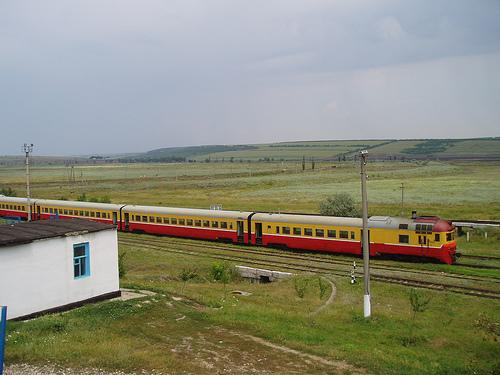What type of building is situated near the train? A small white building with a black roof and blue window frame. Are there any objects situated around the train that are related to transportation infrastructure? Yes, there are railroad tracks, a concrete entrance that goes under the tracks, and a tall wooden pole with a white base. Count the number of cars visible in the train. Four cars. What does the sky look like in the image? The sky is gray and hazy, with clouds indicating a possible overcast day. Identify any unique features on the small building near the train. The small building has a blue window frame, a black roof, and a white exterior. Provide a brief description of the main object in the image. A long yellow and red passenger train is on the tracks beside a small white building. Examine the windows on the train and describe their characteristics. The windows on the side of the train are various sizes, with some being smaller or narrower than others. List the colors of the train in the image. Yellow, red, and gray. Can you describe the surrounding environment of the train? The train is surrounded by brown tracks, a field of grass, and a cloudy gray sky. What is beneath the train tracks in the image? A concrete drainage culvert below the train tracks. 